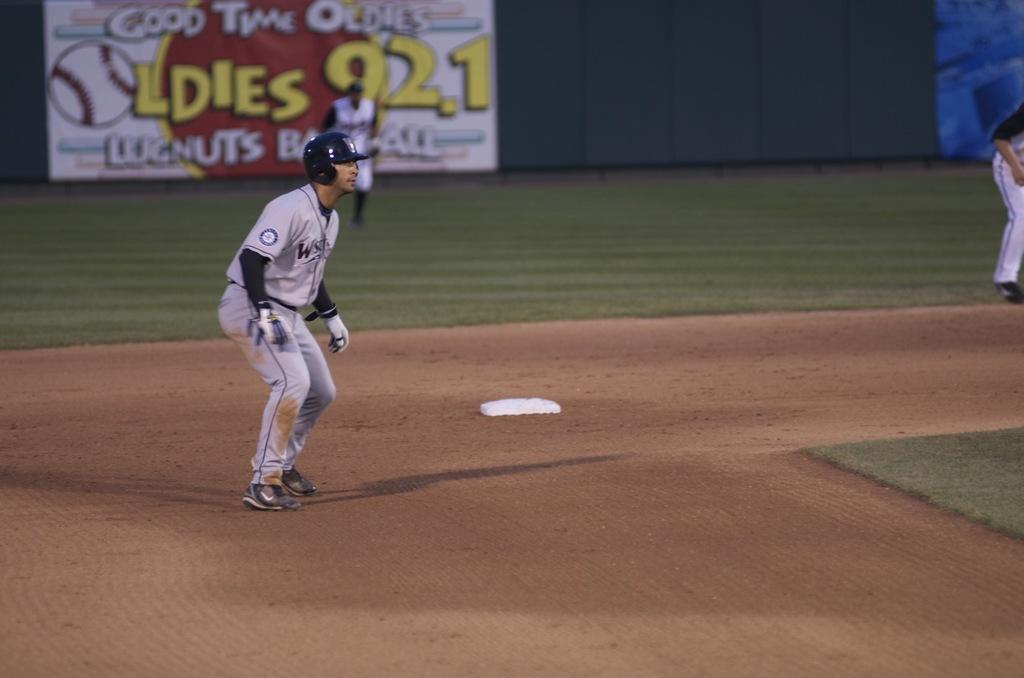<image>
Summarize the visual content of the image. The station in the background is called the Oldies 